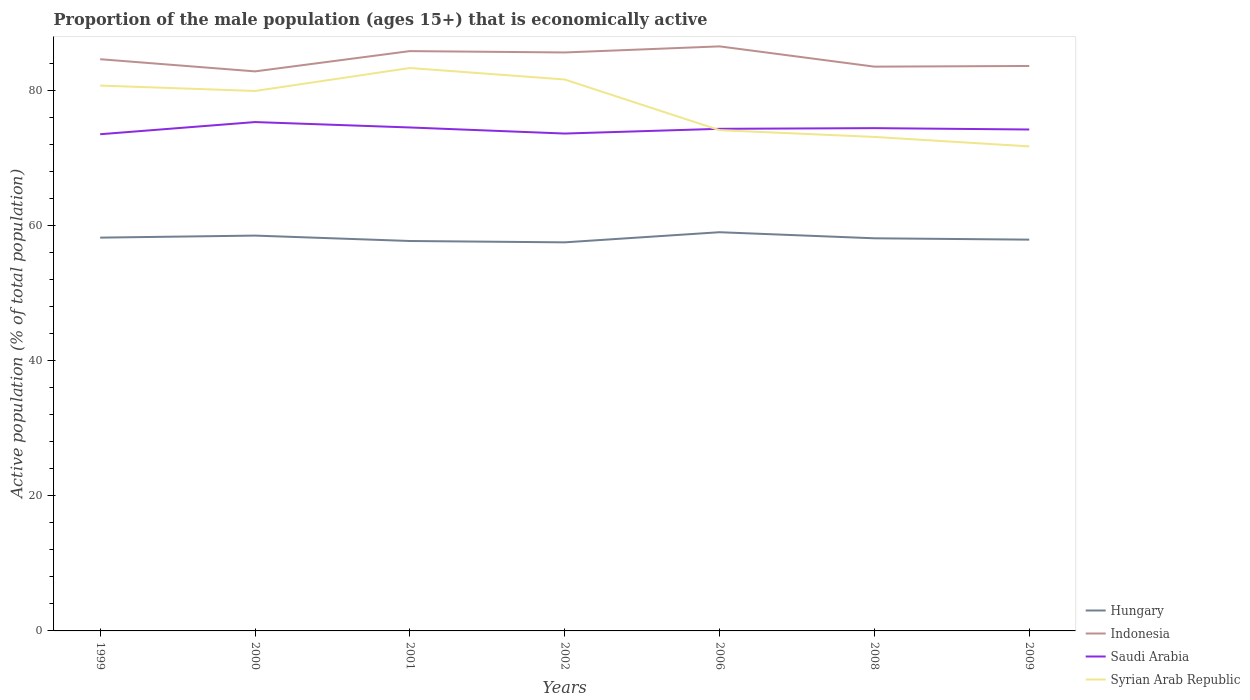How many different coloured lines are there?
Make the answer very short. 4. Does the line corresponding to Hungary intersect with the line corresponding to Saudi Arabia?
Provide a short and direct response. No. Is the number of lines equal to the number of legend labels?
Provide a short and direct response. Yes. Across all years, what is the maximum proportion of the male population that is economically active in Syrian Arab Republic?
Your answer should be compact. 71.7. In which year was the proportion of the male population that is economically active in Hungary maximum?
Offer a very short reply. 2002. What is the difference between the highest and the second highest proportion of the male population that is economically active in Indonesia?
Offer a very short reply. 3.7. What is the difference between the highest and the lowest proportion of the male population that is economically active in Syrian Arab Republic?
Provide a succinct answer. 4. How many years are there in the graph?
Your response must be concise. 7. What is the difference between two consecutive major ticks on the Y-axis?
Your response must be concise. 20. Are the values on the major ticks of Y-axis written in scientific E-notation?
Provide a succinct answer. No. Does the graph contain grids?
Provide a short and direct response. No. How many legend labels are there?
Offer a very short reply. 4. How are the legend labels stacked?
Offer a terse response. Vertical. What is the title of the graph?
Your answer should be very brief. Proportion of the male population (ages 15+) that is economically active. What is the label or title of the Y-axis?
Offer a terse response. Active population (% of total population). What is the Active population (% of total population) in Hungary in 1999?
Provide a short and direct response. 58.2. What is the Active population (% of total population) of Indonesia in 1999?
Your answer should be very brief. 84.6. What is the Active population (% of total population) in Saudi Arabia in 1999?
Offer a very short reply. 73.5. What is the Active population (% of total population) in Syrian Arab Republic in 1999?
Ensure brevity in your answer.  80.7. What is the Active population (% of total population) in Hungary in 2000?
Provide a succinct answer. 58.5. What is the Active population (% of total population) of Indonesia in 2000?
Offer a terse response. 82.8. What is the Active population (% of total population) of Saudi Arabia in 2000?
Keep it short and to the point. 75.3. What is the Active population (% of total population) of Syrian Arab Republic in 2000?
Offer a terse response. 79.9. What is the Active population (% of total population) in Hungary in 2001?
Provide a succinct answer. 57.7. What is the Active population (% of total population) in Indonesia in 2001?
Give a very brief answer. 85.8. What is the Active population (% of total population) in Saudi Arabia in 2001?
Keep it short and to the point. 74.5. What is the Active population (% of total population) of Syrian Arab Republic in 2001?
Your answer should be very brief. 83.3. What is the Active population (% of total population) of Hungary in 2002?
Provide a short and direct response. 57.5. What is the Active population (% of total population) in Indonesia in 2002?
Make the answer very short. 85.6. What is the Active population (% of total population) of Saudi Arabia in 2002?
Your answer should be compact. 73.6. What is the Active population (% of total population) of Syrian Arab Republic in 2002?
Offer a very short reply. 81.6. What is the Active population (% of total population) of Hungary in 2006?
Make the answer very short. 59. What is the Active population (% of total population) of Indonesia in 2006?
Provide a short and direct response. 86.5. What is the Active population (% of total population) in Saudi Arabia in 2006?
Ensure brevity in your answer.  74.3. What is the Active population (% of total population) in Syrian Arab Republic in 2006?
Your answer should be compact. 74.1. What is the Active population (% of total population) of Hungary in 2008?
Keep it short and to the point. 58.1. What is the Active population (% of total population) of Indonesia in 2008?
Provide a short and direct response. 83.5. What is the Active population (% of total population) in Saudi Arabia in 2008?
Offer a very short reply. 74.4. What is the Active population (% of total population) in Syrian Arab Republic in 2008?
Give a very brief answer. 73.1. What is the Active population (% of total population) in Hungary in 2009?
Keep it short and to the point. 57.9. What is the Active population (% of total population) of Indonesia in 2009?
Keep it short and to the point. 83.6. What is the Active population (% of total population) in Saudi Arabia in 2009?
Provide a short and direct response. 74.2. What is the Active population (% of total population) of Syrian Arab Republic in 2009?
Keep it short and to the point. 71.7. Across all years, what is the maximum Active population (% of total population) in Hungary?
Offer a terse response. 59. Across all years, what is the maximum Active population (% of total population) of Indonesia?
Keep it short and to the point. 86.5. Across all years, what is the maximum Active population (% of total population) in Saudi Arabia?
Ensure brevity in your answer.  75.3. Across all years, what is the maximum Active population (% of total population) of Syrian Arab Republic?
Give a very brief answer. 83.3. Across all years, what is the minimum Active population (% of total population) of Hungary?
Your answer should be very brief. 57.5. Across all years, what is the minimum Active population (% of total population) of Indonesia?
Your answer should be compact. 82.8. Across all years, what is the minimum Active population (% of total population) in Saudi Arabia?
Make the answer very short. 73.5. Across all years, what is the minimum Active population (% of total population) of Syrian Arab Republic?
Offer a terse response. 71.7. What is the total Active population (% of total population) in Hungary in the graph?
Your answer should be compact. 406.9. What is the total Active population (% of total population) of Indonesia in the graph?
Offer a very short reply. 592.4. What is the total Active population (% of total population) in Saudi Arabia in the graph?
Your response must be concise. 519.8. What is the total Active population (% of total population) in Syrian Arab Republic in the graph?
Provide a short and direct response. 544.4. What is the difference between the Active population (% of total population) of Hungary in 1999 and that in 2000?
Ensure brevity in your answer.  -0.3. What is the difference between the Active population (% of total population) of Indonesia in 1999 and that in 2000?
Ensure brevity in your answer.  1.8. What is the difference between the Active population (% of total population) in Saudi Arabia in 1999 and that in 2000?
Ensure brevity in your answer.  -1.8. What is the difference between the Active population (% of total population) of Indonesia in 1999 and that in 2001?
Your answer should be very brief. -1.2. What is the difference between the Active population (% of total population) of Syrian Arab Republic in 1999 and that in 2001?
Your answer should be compact. -2.6. What is the difference between the Active population (% of total population) in Hungary in 1999 and that in 2002?
Your answer should be very brief. 0.7. What is the difference between the Active population (% of total population) in Indonesia in 1999 and that in 2002?
Give a very brief answer. -1. What is the difference between the Active population (% of total population) of Indonesia in 1999 and that in 2006?
Your answer should be compact. -1.9. What is the difference between the Active population (% of total population) in Syrian Arab Republic in 1999 and that in 2006?
Give a very brief answer. 6.6. What is the difference between the Active population (% of total population) in Saudi Arabia in 1999 and that in 2008?
Offer a very short reply. -0.9. What is the difference between the Active population (% of total population) of Saudi Arabia in 1999 and that in 2009?
Give a very brief answer. -0.7. What is the difference between the Active population (% of total population) of Hungary in 2000 and that in 2001?
Provide a succinct answer. 0.8. What is the difference between the Active population (% of total population) in Saudi Arabia in 2000 and that in 2001?
Your answer should be very brief. 0.8. What is the difference between the Active population (% of total population) in Syrian Arab Republic in 2000 and that in 2001?
Your answer should be very brief. -3.4. What is the difference between the Active population (% of total population) in Indonesia in 2000 and that in 2002?
Your response must be concise. -2.8. What is the difference between the Active population (% of total population) of Indonesia in 2000 and that in 2006?
Offer a very short reply. -3.7. What is the difference between the Active population (% of total population) of Saudi Arabia in 2000 and that in 2006?
Make the answer very short. 1. What is the difference between the Active population (% of total population) of Hungary in 2000 and that in 2008?
Your response must be concise. 0.4. What is the difference between the Active population (% of total population) in Indonesia in 2000 and that in 2008?
Provide a succinct answer. -0.7. What is the difference between the Active population (% of total population) in Saudi Arabia in 2000 and that in 2008?
Provide a succinct answer. 0.9. What is the difference between the Active population (% of total population) in Syrian Arab Republic in 2000 and that in 2008?
Your answer should be very brief. 6.8. What is the difference between the Active population (% of total population) in Hungary in 2000 and that in 2009?
Offer a terse response. 0.6. What is the difference between the Active population (% of total population) of Saudi Arabia in 2000 and that in 2009?
Give a very brief answer. 1.1. What is the difference between the Active population (% of total population) in Syrian Arab Republic in 2000 and that in 2009?
Keep it short and to the point. 8.2. What is the difference between the Active population (% of total population) of Syrian Arab Republic in 2001 and that in 2002?
Your answer should be compact. 1.7. What is the difference between the Active population (% of total population) in Syrian Arab Republic in 2001 and that in 2006?
Your answer should be compact. 9.2. What is the difference between the Active population (% of total population) of Hungary in 2001 and that in 2008?
Ensure brevity in your answer.  -0.4. What is the difference between the Active population (% of total population) of Indonesia in 2001 and that in 2009?
Your response must be concise. 2.2. What is the difference between the Active population (% of total population) in Saudi Arabia in 2001 and that in 2009?
Offer a terse response. 0.3. What is the difference between the Active population (% of total population) of Indonesia in 2002 and that in 2006?
Your answer should be compact. -0.9. What is the difference between the Active population (% of total population) in Syrian Arab Republic in 2002 and that in 2006?
Your answer should be very brief. 7.5. What is the difference between the Active population (% of total population) of Hungary in 2002 and that in 2008?
Keep it short and to the point. -0.6. What is the difference between the Active population (% of total population) of Saudi Arabia in 2002 and that in 2008?
Ensure brevity in your answer.  -0.8. What is the difference between the Active population (% of total population) of Syrian Arab Republic in 2002 and that in 2008?
Ensure brevity in your answer.  8.5. What is the difference between the Active population (% of total population) of Saudi Arabia in 2002 and that in 2009?
Ensure brevity in your answer.  -0.6. What is the difference between the Active population (% of total population) of Hungary in 2006 and that in 2008?
Offer a very short reply. 0.9. What is the difference between the Active population (% of total population) in Saudi Arabia in 2006 and that in 2008?
Offer a terse response. -0.1. What is the difference between the Active population (% of total population) of Hungary in 2006 and that in 2009?
Offer a terse response. 1.1. What is the difference between the Active population (% of total population) in Hungary in 2008 and that in 2009?
Your answer should be compact. 0.2. What is the difference between the Active population (% of total population) in Indonesia in 2008 and that in 2009?
Offer a very short reply. -0.1. What is the difference between the Active population (% of total population) of Syrian Arab Republic in 2008 and that in 2009?
Keep it short and to the point. 1.4. What is the difference between the Active population (% of total population) in Hungary in 1999 and the Active population (% of total population) in Indonesia in 2000?
Provide a succinct answer. -24.6. What is the difference between the Active population (% of total population) of Hungary in 1999 and the Active population (% of total population) of Saudi Arabia in 2000?
Offer a terse response. -17.1. What is the difference between the Active population (% of total population) of Hungary in 1999 and the Active population (% of total population) of Syrian Arab Republic in 2000?
Your answer should be compact. -21.7. What is the difference between the Active population (% of total population) in Indonesia in 1999 and the Active population (% of total population) in Saudi Arabia in 2000?
Your answer should be very brief. 9.3. What is the difference between the Active population (% of total population) of Indonesia in 1999 and the Active population (% of total population) of Syrian Arab Republic in 2000?
Your answer should be compact. 4.7. What is the difference between the Active population (% of total population) in Hungary in 1999 and the Active population (% of total population) in Indonesia in 2001?
Provide a succinct answer. -27.6. What is the difference between the Active population (% of total population) in Hungary in 1999 and the Active population (% of total population) in Saudi Arabia in 2001?
Provide a short and direct response. -16.3. What is the difference between the Active population (% of total population) of Hungary in 1999 and the Active population (% of total population) of Syrian Arab Republic in 2001?
Make the answer very short. -25.1. What is the difference between the Active population (% of total population) of Indonesia in 1999 and the Active population (% of total population) of Syrian Arab Republic in 2001?
Your answer should be very brief. 1.3. What is the difference between the Active population (% of total population) of Saudi Arabia in 1999 and the Active population (% of total population) of Syrian Arab Republic in 2001?
Offer a very short reply. -9.8. What is the difference between the Active population (% of total population) in Hungary in 1999 and the Active population (% of total population) in Indonesia in 2002?
Your answer should be very brief. -27.4. What is the difference between the Active population (% of total population) of Hungary in 1999 and the Active population (% of total population) of Saudi Arabia in 2002?
Keep it short and to the point. -15.4. What is the difference between the Active population (% of total population) of Hungary in 1999 and the Active population (% of total population) of Syrian Arab Republic in 2002?
Make the answer very short. -23.4. What is the difference between the Active population (% of total population) of Indonesia in 1999 and the Active population (% of total population) of Saudi Arabia in 2002?
Your answer should be compact. 11. What is the difference between the Active population (% of total population) of Saudi Arabia in 1999 and the Active population (% of total population) of Syrian Arab Republic in 2002?
Offer a very short reply. -8.1. What is the difference between the Active population (% of total population) in Hungary in 1999 and the Active population (% of total population) in Indonesia in 2006?
Keep it short and to the point. -28.3. What is the difference between the Active population (% of total population) of Hungary in 1999 and the Active population (% of total population) of Saudi Arabia in 2006?
Ensure brevity in your answer.  -16.1. What is the difference between the Active population (% of total population) of Hungary in 1999 and the Active population (% of total population) of Syrian Arab Republic in 2006?
Your answer should be very brief. -15.9. What is the difference between the Active population (% of total population) of Indonesia in 1999 and the Active population (% of total population) of Saudi Arabia in 2006?
Make the answer very short. 10.3. What is the difference between the Active population (% of total population) of Indonesia in 1999 and the Active population (% of total population) of Syrian Arab Republic in 2006?
Offer a very short reply. 10.5. What is the difference between the Active population (% of total population) in Hungary in 1999 and the Active population (% of total population) in Indonesia in 2008?
Offer a terse response. -25.3. What is the difference between the Active population (% of total population) in Hungary in 1999 and the Active population (% of total population) in Saudi Arabia in 2008?
Provide a short and direct response. -16.2. What is the difference between the Active population (% of total population) of Hungary in 1999 and the Active population (% of total population) of Syrian Arab Republic in 2008?
Keep it short and to the point. -14.9. What is the difference between the Active population (% of total population) in Hungary in 1999 and the Active population (% of total population) in Indonesia in 2009?
Provide a succinct answer. -25.4. What is the difference between the Active population (% of total population) in Hungary in 1999 and the Active population (% of total population) in Saudi Arabia in 2009?
Your response must be concise. -16. What is the difference between the Active population (% of total population) of Hungary in 1999 and the Active population (% of total population) of Syrian Arab Republic in 2009?
Offer a terse response. -13.5. What is the difference between the Active population (% of total population) in Saudi Arabia in 1999 and the Active population (% of total population) in Syrian Arab Republic in 2009?
Offer a terse response. 1.8. What is the difference between the Active population (% of total population) of Hungary in 2000 and the Active population (% of total population) of Indonesia in 2001?
Your answer should be very brief. -27.3. What is the difference between the Active population (% of total population) of Hungary in 2000 and the Active population (% of total population) of Syrian Arab Republic in 2001?
Offer a terse response. -24.8. What is the difference between the Active population (% of total population) of Indonesia in 2000 and the Active population (% of total population) of Saudi Arabia in 2001?
Your response must be concise. 8.3. What is the difference between the Active population (% of total population) in Saudi Arabia in 2000 and the Active population (% of total population) in Syrian Arab Republic in 2001?
Provide a succinct answer. -8. What is the difference between the Active population (% of total population) of Hungary in 2000 and the Active population (% of total population) of Indonesia in 2002?
Provide a short and direct response. -27.1. What is the difference between the Active population (% of total population) in Hungary in 2000 and the Active population (% of total population) in Saudi Arabia in 2002?
Offer a very short reply. -15.1. What is the difference between the Active population (% of total population) in Hungary in 2000 and the Active population (% of total population) in Syrian Arab Republic in 2002?
Provide a short and direct response. -23.1. What is the difference between the Active population (% of total population) in Indonesia in 2000 and the Active population (% of total population) in Syrian Arab Republic in 2002?
Provide a succinct answer. 1.2. What is the difference between the Active population (% of total population) of Hungary in 2000 and the Active population (% of total population) of Indonesia in 2006?
Your answer should be compact. -28. What is the difference between the Active population (% of total population) of Hungary in 2000 and the Active population (% of total population) of Saudi Arabia in 2006?
Keep it short and to the point. -15.8. What is the difference between the Active population (% of total population) of Hungary in 2000 and the Active population (% of total population) of Syrian Arab Republic in 2006?
Ensure brevity in your answer.  -15.6. What is the difference between the Active population (% of total population) of Indonesia in 2000 and the Active population (% of total population) of Syrian Arab Republic in 2006?
Provide a succinct answer. 8.7. What is the difference between the Active population (% of total population) in Saudi Arabia in 2000 and the Active population (% of total population) in Syrian Arab Republic in 2006?
Provide a short and direct response. 1.2. What is the difference between the Active population (% of total population) of Hungary in 2000 and the Active population (% of total population) of Indonesia in 2008?
Your answer should be compact. -25. What is the difference between the Active population (% of total population) of Hungary in 2000 and the Active population (% of total population) of Saudi Arabia in 2008?
Your answer should be compact. -15.9. What is the difference between the Active population (% of total population) in Hungary in 2000 and the Active population (% of total population) in Syrian Arab Republic in 2008?
Offer a very short reply. -14.6. What is the difference between the Active population (% of total population) in Saudi Arabia in 2000 and the Active population (% of total population) in Syrian Arab Republic in 2008?
Provide a short and direct response. 2.2. What is the difference between the Active population (% of total population) of Hungary in 2000 and the Active population (% of total population) of Indonesia in 2009?
Give a very brief answer. -25.1. What is the difference between the Active population (% of total population) of Hungary in 2000 and the Active population (% of total population) of Saudi Arabia in 2009?
Keep it short and to the point. -15.7. What is the difference between the Active population (% of total population) in Hungary in 2000 and the Active population (% of total population) in Syrian Arab Republic in 2009?
Ensure brevity in your answer.  -13.2. What is the difference between the Active population (% of total population) of Indonesia in 2000 and the Active population (% of total population) of Syrian Arab Republic in 2009?
Your response must be concise. 11.1. What is the difference between the Active population (% of total population) in Hungary in 2001 and the Active population (% of total population) in Indonesia in 2002?
Your response must be concise. -27.9. What is the difference between the Active population (% of total population) of Hungary in 2001 and the Active population (% of total population) of Saudi Arabia in 2002?
Make the answer very short. -15.9. What is the difference between the Active population (% of total population) of Hungary in 2001 and the Active population (% of total population) of Syrian Arab Republic in 2002?
Keep it short and to the point. -23.9. What is the difference between the Active population (% of total population) in Indonesia in 2001 and the Active population (% of total population) in Syrian Arab Republic in 2002?
Ensure brevity in your answer.  4.2. What is the difference between the Active population (% of total population) of Saudi Arabia in 2001 and the Active population (% of total population) of Syrian Arab Republic in 2002?
Give a very brief answer. -7.1. What is the difference between the Active population (% of total population) of Hungary in 2001 and the Active population (% of total population) of Indonesia in 2006?
Provide a succinct answer. -28.8. What is the difference between the Active population (% of total population) in Hungary in 2001 and the Active population (% of total population) in Saudi Arabia in 2006?
Offer a very short reply. -16.6. What is the difference between the Active population (% of total population) in Hungary in 2001 and the Active population (% of total population) in Syrian Arab Republic in 2006?
Offer a very short reply. -16.4. What is the difference between the Active population (% of total population) of Indonesia in 2001 and the Active population (% of total population) of Saudi Arabia in 2006?
Keep it short and to the point. 11.5. What is the difference between the Active population (% of total population) in Indonesia in 2001 and the Active population (% of total population) in Syrian Arab Republic in 2006?
Make the answer very short. 11.7. What is the difference between the Active population (% of total population) in Hungary in 2001 and the Active population (% of total population) in Indonesia in 2008?
Offer a terse response. -25.8. What is the difference between the Active population (% of total population) of Hungary in 2001 and the Active population (% of total population) of Saudi Arabia in 2008?
Give a very brief answer. -16.7. What is the difference between the Active population (% of total population) of Hungary in 2001 and the Active population (% of total population) of Syrian Arab Republic in 2008?
Offer a very short reply. -15.4. What is the difference between the Active population (% of total population) of Indonesia in 2001 and the Active population (% of total population) of Saudi Arabia in 2008?
Your answer should be compact. 11.4. What is the difference between the Active population (% of total population) of Saudi Arabia in 2001 and the Active population (% of total population) of Syrian Arab Republic in 2008?
Provide a short and direct response. 1.4. What is the difference between the Active population (% of total population) of Hungary in 2001 and the Active population (% of total population) of Indonesia in 2009?
Provide a succinct answer. -25.9. What is the difference between the Active population (% of total population) of Hungary in 2001 and the Active population (% of total population) of Saudi Arabia in 2009?
Your response must be concise. -16.5. What is the difference between the Active population (% of total population) in Indonesia in 2001 and the Active population (% of total population) in Saudi Arabia in 2009?
Keep it short and to the point. 11.6. What is the difference between the Active population (% of total population) in Indonesia in 2001 and the Active population (% of total population) in Syrian Arab Republic in 2009?
Provide a short and direct response. 14.1. What is the difference between the Active population (% of total population) in Hungary in 2002 and the Active population (% of total population) in Saudi Arabia in 2006?
Make the answer very short. -16.8. What is the difference between the Active population (% of total population) in Hungary in 2002 and the Active population (% of total population) in Syrian Arab Republic in 2006?
Provide a succinct answer. -16.6. What is the difference between the Active population (% of total population) of Hungary in 2002 and the Active population (% of total population) of Saudi Arabia in 2008?
Ensure brevity in your answer.  -16.9. What is the difference between the Active population (% of total population) in Hungary in 2002 and the Active population (% of total population) in Syrian Arab Republic in 2008?
Keep it short and to the point. -15.6. What is the difference between the Active population (% of total population) of Hungary in 2002 and the Active population (% of total population) of Indonesia in 2009?
Provide a short and direct response. -26.1. What is the difference between the Active population (% of total population) of Hungary in 2002 and the Active population (% of total population) of Saudi Arabia in 2009?
Provide a short and direct response. -16.7. What is the difference between the Active population (% of total population) of Indonesia in 2002 and the Active population (% of total population) of Syrian Arab Republic in 2009?
Give a very brief answer. 13.9. What is the difference between the Active population (% of total population) in Saudi Arabia in 2002 and the Active population (% of total population) in Syrian Arab Republic in 2009?
Offer a terse response. 1.9. What is the difference between the Active population (% of total population) of Hungary in 2006 and the Active population (% of total population) of Indonesia in 2008?
Give a very brief answer. -24.5. What is the difference between the Active population (% of total population) of Hungary in 2006 and the Active population (% of total population) of Saudi Arabia in 2008?
Provide a succinct answer. -15.4. What is the difference between the Active population (% of total population) of Hungary in 2006 and the Active population (% of total population) of Syrian Arab Republic in 2008?
Make the answer very short. -14.1. What is the difference between the Active population (% of total population) in Indonesia in 2006 and the Active population (% of total population) in Saudi Arabia in 2008?
Offer a very short reply. 12.1. What is the difference between the Active population (% of total population) in Indonesia in 2006 and the Active population (% of total population) in Syrian Arab Republic in 2008?
Keep it short and to the point. 13.4. What is the difference between the Active population (% of total population) in Hungary in 2006 and the Active population (% of total population) in Indonesia in 2009?
Make the answer very short. -24.6. What is the difference between the Active population (% of total population) in Hungary in 2006 and the Active population (% of total population) in Saudi Arabia in 2009?
Give a very brief answer. -15.2. What is the difference between the Active population (% of total population) in Hungary in 2006 and the Active population (% of total population) in Syrian Arab Republic in 2009?
Your answer should be compact. -12.7. What is the difference between the Active population (% of total population) of Indonesia in 2006 and the Active population (% of total population) of Saudi Arabia in 2009?
Your answer should be compact. 12.3. What is the difference between the Active population (% of total population) in Indonesia in 2006 and the Active population (% of total population) in Syrian Arab Republic in 2009?
Keep it short and to the point. 14.8. What is the difference between the Active population (% of total population) in Saudi Arabia in 2006 and the Active population (% of total population) in Syrian Arab Republic in 2009?
Make the answer very short. 2.6. What is the difference between the Active population (% of total population) of Hungary in 2008 and the Active population (% of total population) of Indonesia in 2009?
Ensure brevity in your answer.  -25.5. What is the difference between the Active population (% of total population) of Hungary in 2008 and the Active population (% of total population) of Saudi Arabia in 2009?
Ensure brevity in your answer.  -16.1. What is the difference between the Active population (% of total population) in Indonesia in 2008 and the Active population (% of total population) in Saudi Arabia in 2009?
Offer a very short reply. 9.3. What is the difference between the Active population (% of total population) of Indonesia in 2008 and the Active population (% of total population) of Syrian Arab Republic in 2009?
Offer a terse response. 11.8. What is the average Active population (% of total population) in Hungary per year?
Make the answer very short. 58.13. What is the average Active population (% of total population) of Indonesia per year?
Offer a very short reply. 84.63. What is the average Active population (% of total population) in Saudi Arabia per year?
Provide a succinct answer. 74.26. What is the average Active population (% of total population) in Syrian Arab Republic per year?
Provide a short and direct response. 77.77. In the year 1999, what is the difference between the Active population (% of total population) of Hungary and Active population (% of total population) of Indonesia?
Provide a succinct answer. -26.4. In the year 1999, what is the difference between the Active population (% of total population) of Hungary and Active population (% of total population) of Saudi Arabia?
Keep it short and to the point. -15.3. In the year 1999, what is the difference between the Active population (% of total population) in Hungary and Active population (% of total population) in Syrian Arab Republic?
Ensure brevity in your answer.  -22.5. In the year 1999, what is the difference between the Active population (% of total population) of Indonesia and Active population (% of total population) of Syrian Arab Republic?
Keep it short and to the point. 3.9. In the year 2000, what is the difference between the Active population (% of total population) in Hungary and Active population (% of total population) in Indonesia?
Your response must be concise. -24.3. In the year 2000, what is the difference between the Active population (% of total population) in Hungary and Active population (% of total population) in Saudi Arabia?
Your answer should be compact. -16.8. In the year 2000, what is the difference between the Active population (% of total population) of Hungary and Active population (% of total population) of Syrian Arab Republic?
Give a very brief answer. -21.4. In the year 2000, what is the difference between the Active population (% of total population) in Indonesia and Active population (% of total population) in Saudi Arabia?
Your answer should be very brief. 7.5. In the year 2000, what is the difference between the Active population (% of total population) in Saudi Arabia and Active population (% of total population) in Syrian Arab Republic?
Give a very brief answer. -4.6. In the year 2001, what is the difference between the Active population (% of total population) of Hungary and Active population (% of total population) of Indonesia?
Your answer should be very brief. -28.1. In the year 2001, what is the difference between the Active population (% of total population) of Hungary and Active population (% of total population) of Saudi Arabia?
Your answer should be very brief. -16.8. In the year 2001, what is the difference between the Active population (% of total population) in Hungary and Active population (% of total population) in Syrian Arab Republic?
Ensure brevity in your answer.  -25.6. In the year 2001, what is the difference between the Active population (% of total population) of Saudi Arabia and Active population (% of total population) of Syrian Arab Republic?
Offer a very short reply. -8.8. In the year 2002, what is the difference between the Active population (% of total population) in Hungary and Active population (% of total population) in Indonesia?
Provide a succinct answer. -28.1. In the year 2002, what is the difference between the Active population (% of total population) of Hungary and Active population (% of total population) of Saudi Arabia?
Your response must be concise. -16.1. In the year 2002, what is the difference between the Active population (% of total population) in Hungary and Active population (% of total population) in Syrian Arab Republic?
Ensure brevity in your answer.  -24.1. In the year 2002, what is the difference between the Active population (% of total population) of Indonesia and Active population (% of total population) of Saudi Arabia?
Your response must be concise. 12. In the year 2002, what is the difference between the Active population (% of total population) in Indonesia and Active population (% of total population) in Syrian Arab Republic?
Give a very brief answer. 4. In the year 2006, what is the difference between the Active population (% of total population) in Hungary and Active population (% of total population) in Indonesia?
Offer a terse response. -27.5. In the year 2006, what is the difference between the Active population (% of total population) of Hungary and Active population (% of total population) of Saudi Arabia?
Provide a short and direct response. -15.3. In the year 2006, what is the difference between the Active population (% of total population) in Hungary and Active population (% of total population) in Syrian Arab Republic?
Your answer should be very brief. -15.1. In the year 2006, what is the difference between the Active population (% of total population) in Indonesia and Active population (% of total population) in Saudi Arabia?
Keep it short and to the point. 12.2. In the year 2008, what is the difference between the Active population (% of total population) of Hungary and Active population (% of total population) of Indonesia?
Offer a very short reply. -25.4. In the year 2008, what is the difference between the Active population (% of total population) of Hungary and Active population (% of total population) of Saudi Arabia?
Ensure brevity in your answer.  -16.3. In the year 2008, what is the difference between the Active population (% of total population) in Indonesia and Active population (% of total population) in Syrian Arab Republic?
Your answer should be very brief. 10.4. In the year 2009, what is the difference between the Active population (% of total population) of Hungary and Active population (% of total population) of Indonesia?
Make the answer very short. -25.7. In the year 2009, what is the difference between the Active population (% of total population) of Hungary and Active population (% of total population) of Saudi Arabia?
Offer a very short reply. -16.3. In the year 2009, what is the difference between the Active population (% of total population) of Hungary and Active population (% of total population) of Syrian Arab Republic?
Offer a very short reply. -13.8. What is the ratio of the Active population (% of total population) of Hungary in 1999 to that in 2000?
Your response must be concise. 0.99. What is the ratio of the Active population (% of total population) of Indonesia in 1999 to that in 2000?
Offer a very short reply. 1.02. What is the ratio of the Active population (% of total population) of Saudi Arabia in 1999 to that in 2000?
Your answer should be compact. 0.98. What is the ratio of the Active population (% of total population) of Syrian Arab Republic in 1999 to that in 2000?
Keep it short and to the point. 1.01. What is the ratio of the Active population (% of total population) in Hungary in 1999 to that in 2001?
Offer a very short reply. 1.01. What is the ratio of the Active population (% of total population) of Indonesia in 1999 to that in 2001?
Provide a succinct answer. 0.99. What is the ratio of the Active population (% of total population) of Saudi Arabia in 1999 to that in 2001?
Ensure brevity in your answer.  0.99. What is the ratio of the Active population (% of total population) in Syrian Arab Republic in 1999 to that in 2001?
Provide a short and direct response. 0.97. What is the ratio of the Active population (% of total population) of Hungary in 1999 to that in 2002?
Provide a succinct answer. 1.01. What is the ratio of the Active population (% of total population) in Indonesia in 1999 to that in 2002?
Provide a succinct answer. 0.99. What is the ratio of the Active population (% of total population) of Saudi Arabia in 1999 to that in 2002?
Offer a very short reply. 1. What is the ratio of the Active population (% of total population) in Hungary in 1999 to that in 2006?
Provide a short and direct response. 0.99. What is the ratio of the Active population (% of total population) in Indonesia in 1999 to that in 2006?
Ensure brevity in your answer.  0.98. What is the ratio of the Active population (% of total population) of Saudi Arabia in 1999 to that in 2006?
Keep it short and to the point. 0.99. What is the ratio of the Active population (% of total population) of Syrian Arab Republic in 1999 to that in 2006?
Provide a succinct answer. 1.09. What is the ratio of the Active population (% of total population) of Indonesia in 1999 to that in 2008?
Give a very brief answer. 1.01. What is the ratio of the Active population (% of total population) in Saudi Arabia in 1999 to that in 2008?
Your answer should be very brief. 0.99. What is the ratio of the Active population (% of total population) of Syrian Arab Republic in 1999 to that in 2008?
Offer a terse response. 1.1. What is the ratio of the Active population (% of total population) of Indonesia in 1999 to that in 2009?
Ensure brevity in your answer.  1.01. What is the ratio of the Active population (% of total population) in Saudi Arabia in 1999 to that in 2009?
Offer a very short reply. 0.99. What is the ratio of the Active population (% of total population) of Syrian Arab Republic in 1999 to that in 2009?
Keep it short and to the point. 1.13. What is the ratio of the Active population (% of total population) of Hungary in 2000 to that in 2001?
Provide a succinct answer. 1.01. What is the ratio of the Active population (% of total population) of Saudi Arabia in 2000 to that in 2001?
Provide a succinct answer. 1.01. What is the ratio of the Active population (% of total population) of Syrian Arab Republic in 2000 to that in 2001?
Offer a very short reply. 0.96. What is the ratio of the Active population (% of total population) of Hungary in 2000 to that in 2002?
Offer a very short reply. 1.02. What is the ratio of the Active population (% of total population) in Indonesia in 2000 to that in 2002?
Give a very brief answer. 0.97. What is the ratio of the Active population (% of total population) of Saudi Arabia in 2000 to that in 2002?
Make the answer very short. 1.02. What is the ratio of the Active population (% of total population) in Syrian Arab Republic in 2000 to that in 2002?
Give a very brief answer. 0.98. What is the ratio of the Active population (% of total population) in Indonesia in 2000 to that in 2006?
Your response must be concise. 0.96. What is the ratio of the Active population (% of total population) of Saudi Arabia in 2000 to that in 2006?
Your answer should be compact. 1.01. What is the ratio of the Active population (% of total population) in Syrian Arab Republic in 2000 to that in 2006?
Provide a succinct answer. 1.08. What is the ratio of the Active population (% of total population) in Saudi Arabia in 2000 to that in 2008?
Offer a terse response. 1.01. What is the ratio of the Active population (% of total population) in Syrian Arab Republic in 2000 to that in 2008?
Your answer should be very brief. 1.09. What is the ratio of the Active population (% of total population) in Hungary in 2000 to that in 2009?
Keep it short and to the point. 1.01. What is the ratio of the Active population (% of total population) of Saudi Arabia in 2000 to that in 2009?
Provide a succinct answer. 1.01. What is the ratio of the Active population (% of total population) in Syrian Arab Republic in 2000 to that in 2009?
Offer a very short reply. 1.11. What is the ratio of the Active population (% of total population) in Indonesia in 2001 to that in 2002?
Make the answer very short. 1. What is the ratio of the Active population (% of total population) in Saudi Arabia in 2001 to that in 2002?
Provide a short and direct response. 1.01. What is the ratio of the Active population (% of total population) of Syrian Arab Republic in 2001 to that in 2002?
Provide a short and direct response. 1.02. What is the ratio of the Active population (% of total population) in Hungary in 2001 to that in 2006?
Make the answer very short. 0.98. What is the ratio of the Active population (% of total population) of Indonesia in 2001 to that in 2006?
Ensure brevity in your answer.  0.99. What is the ratio of the Active population (% of total population) in Syrian Arab Republic in 2001 to that in 2006?
Provide a short and direct response. 1.12. What is the ratio of the Active population (% of total population) in Hungary in 2001 to that in 2008?
Your answer should be very brief. 0.99. What is the ratio of the Active population (% of total population) in Indonesia in 2001 to that in 2008?
Provide a succinct answer. 1.03. What is the ratio of the Active population (% of total population) of Saudi Arabia in 2001 to that in 2008?
Your answer should be very brief. 1. What is the ratio of the Active population (% of total population) of Syrian Arab Republic in 2001 to that in 2008?
Ensure brevity in your answer.  1.14. What is the ratio of the Active population (% of total population) of Hungary in 2001 to that in 2009?
Give a very brief answer. 1. What is the ratio of the Active population (% of total population) of Indonesia in 2001 to that in 2009?
Keep it short and to the point. 1.03. What is the ratio of the Active population (% of total population) in Syrian Arab Republic in 2001 to that in 2009?
Ensure brevity in your answer.  1.16. What is the ratio of the Active population (% of total population) in Hungary in 2002 to that in 2006?
Give a very brief answer. 0.97. What is the ratio of the Active population (% of total population) in Saudi Arabia in 2002 to that in 2006?
Keep it short and to the point. 0.99. What is the ratio of the Active population (% of total population) in Syrian Arab Republic in 2002 to that in 2006?
Offer a very short reply. 1.1. What is the ratio of the Active population (% of total population) in Indonesia in 2002 to that in 2008?
Ensure brevity in your answer.  1.03. What is the ratio of the Active population (% of total population) of Syrian Arab Republic in 2002 to that in 2008?
Offer a terse response. 1.12. What is the ratio of the Active population (% of total population) in Hungary in 2002 to that in 2009?
Offer a terse response. 0.99. What is the ratio of the Active population (% of total population) in Indonesia in 2002 to that in 2009?
Your response must be concise. 1.02. What is the ratio of the Active population (% of total population) in Syrian Arab Republic in 2002 to that in 2009?
Your answer should be compact. 1.14. What is the ratio of the Active population (% of total population) of Hungary in 2006 to that in 2008?
Your response must be concise. 1.02. What is the ratio of the Active population (% of total population) in Indonesia in 2006 to that in 2008?
Keep it short and to the point. 1.04. What is the ratio of the Active population (% of total population) of Saudi Arabia in 2006 to that in 2008?
Provide a succinct answer. 1. What is the ratio of the Active population (% of total population) in Syrian Arab Republic in 2006 to that in 2008?
Make the answer very short. 1.01. What is the ratio of the Active population (% of total population) of Indonesia in 2006 to that in 2009?
Offer a terse response. 1.03. What is the ratio of the Active population (% of total population) of Saudi Arabia in 2006 to that in 2009?
Your answer should be very brief. 1. What is the ratio of the Active population (% of total population) in Syrian Arab Republic in 2006 to that in 2009?
Keep it short and to the point. 1.03. What is the ratio of the Active population (% of total population) in Hungary in 2008 to that in 2009?
Keep it short and to the point. 1. What is the ratio of the Active population (% of total population) of Indonesia in 2008 to that in 2009?
Provide a short and direct response. 1. What is the ratio of the Active population (% of total population) of Saudi Arabia in 2008 to that in 2009?
Offer a terse response. 1. What is the ratio of the Active population (% of total population) of Syrian Arab Republic in 2008 to that in 2009?
Your answer should be very brief. 1.02. What is the difference between the highest and the second highest Active population (% of total population) of Hungary?
Your answer should be very brief. 0.5. What is the difference between the highest and the lowest Active population (% of total population) in Hungary?
Provide a short and direct response. 1.5. What is the difference between the highest and the lowest Active population (% of total population) in Saudi Arabia?
Keep it short and to the point. 1.8. What is the difference between the highest and the lowest Active population (% of total population) of Syrian Arab Republic?
Provide a succinct answer. 11.6. 